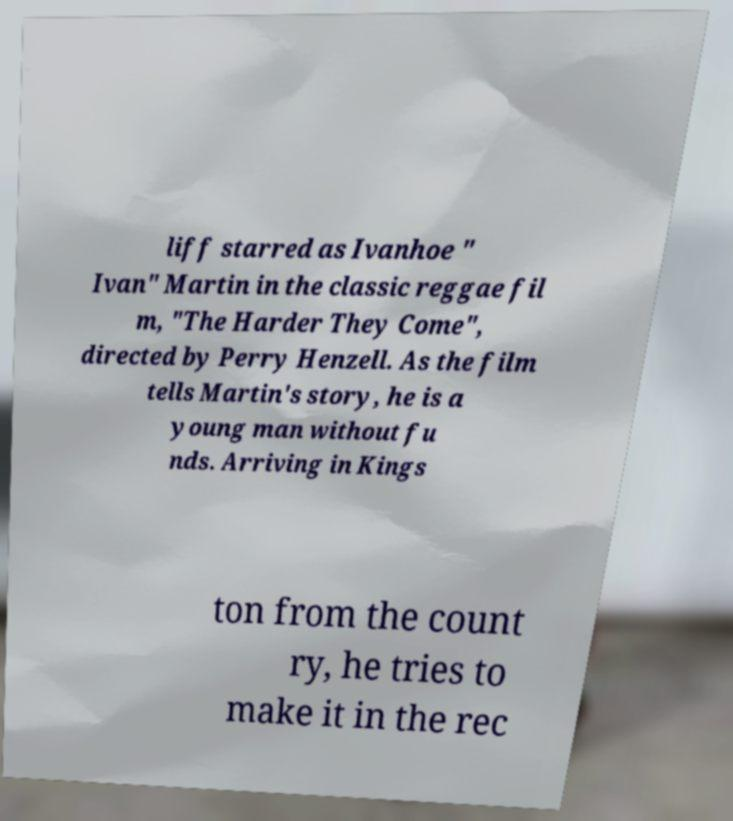Could you extract and type out the text from this image? liff starred as Ivanhoe " Ivan" Martin in the classic reggae fil m, "The Harder They Come", directed by Perry Henzell. As the film tells Martin's story, he is a young man without fu nds. Arriving in Kings ton from the count ry, he tries to make it in the rec 